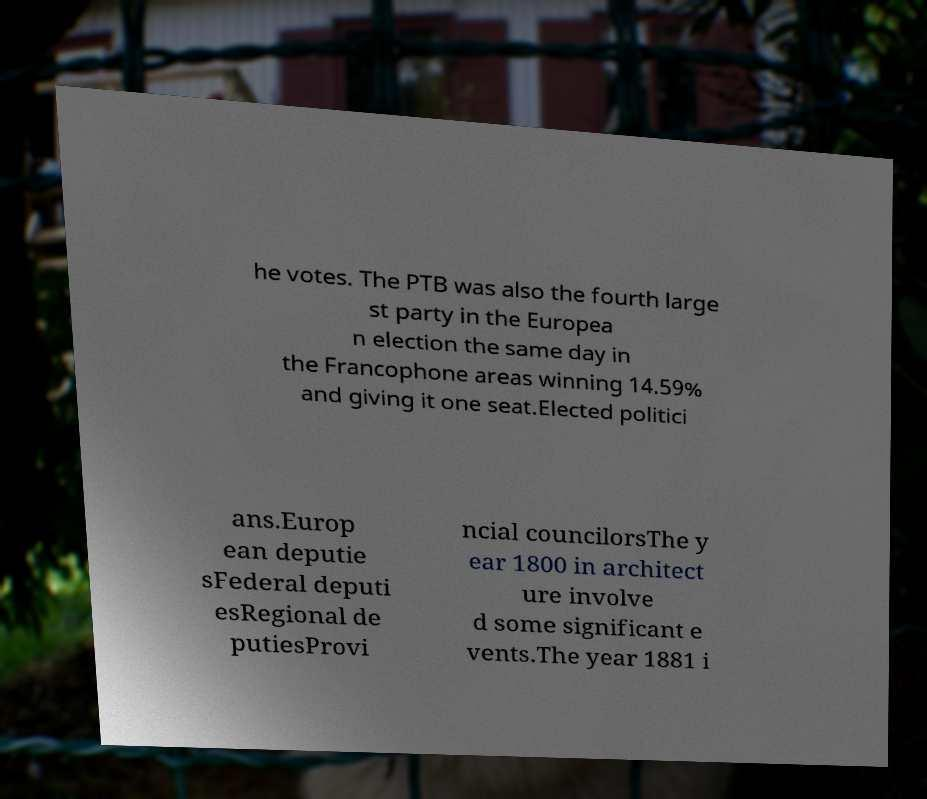Can you accurately transcribe the text from the provided image for me? he votes. The PTB was also the fourth large st party in the Europea n election the same day in the Francophone areas winning 14.59% and giving it one seat.Elected politici ans.Europ ean deputie sFederal deputi esRegional de putiesProvi ncial councilorsThe y ear 1800 in architect ure involve d some significant e vents.The year 1881 i 